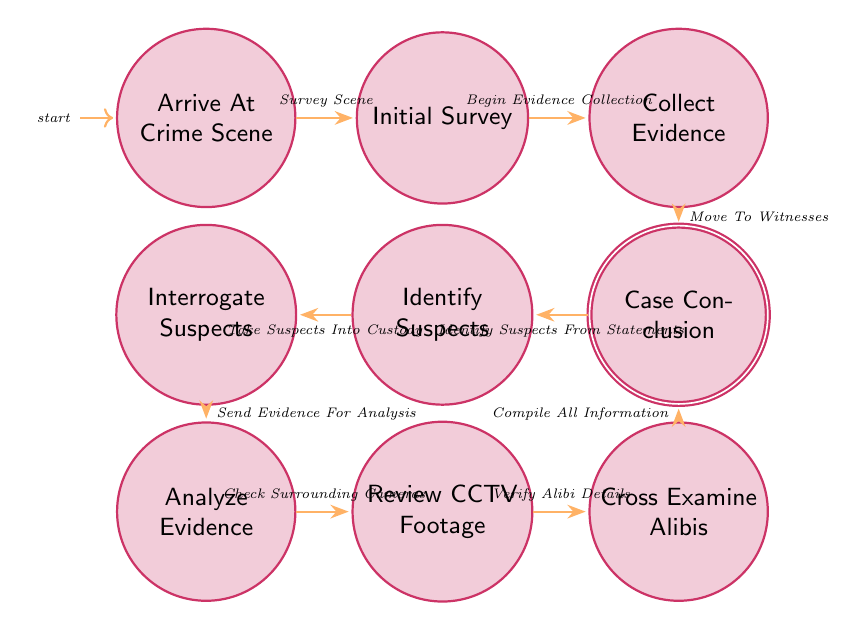What is the initial state of the diagram? The initial state is where the investigation begins, which is represented as "Arrive At Crime Scene".
Answer: Arrive At Crime Scene How many states are there in this diagram? Counting all the unique nodes presented, there are a total of 10 states in the diagram.
Answer: 10 What is the action taken after "Initial Survey"? The action taken from "Initial Survey" to the next state is "Begin Evidence Collection".
Answer: Begin Evidence Collection After collecting evidence, which step follows? The flow from "Collect Evidence" indicates that the next state is "Interview Witnesses".
Answer: Interview Witnesses What is the last state before reaching the conclusion? The state just before the final conclusion is "Cross Examine Alibis".
Answer: Cross Examine Alibis How many transitions are there in total? By counting the arrows connecting the states in the diagram, there are 9 transitions in total.
Answer: 9 What is the relationship between "Identify Suspects" and "Interrogate Suspects"? The transition is that "Take Suspects Into Custody" is the action moving from "Identify Suspects" to "Interrogate Suspects".
Answer: Take Suspects Into Custody Which two states have an action of "Check Surrounding Cameras"? The state "Analyze Evidence" transitions to "Review CCTV Footage" with the action "Check Surrounding Cameras".
Answer: Analyze Evidence, Review CCTV Footage If evidence is sent for analysis, which state is the next? After the state "Interrogate Suspects", which sends the evidence for analysis, the next state is "Analyze Evidence".
Answer: Analyze Evidence What is the final goal of the entire process? The ultimate goal of this finite state machine is the "Case Conclusion", where all information is compiled and reviewed.
Answer: Case Conclusion 